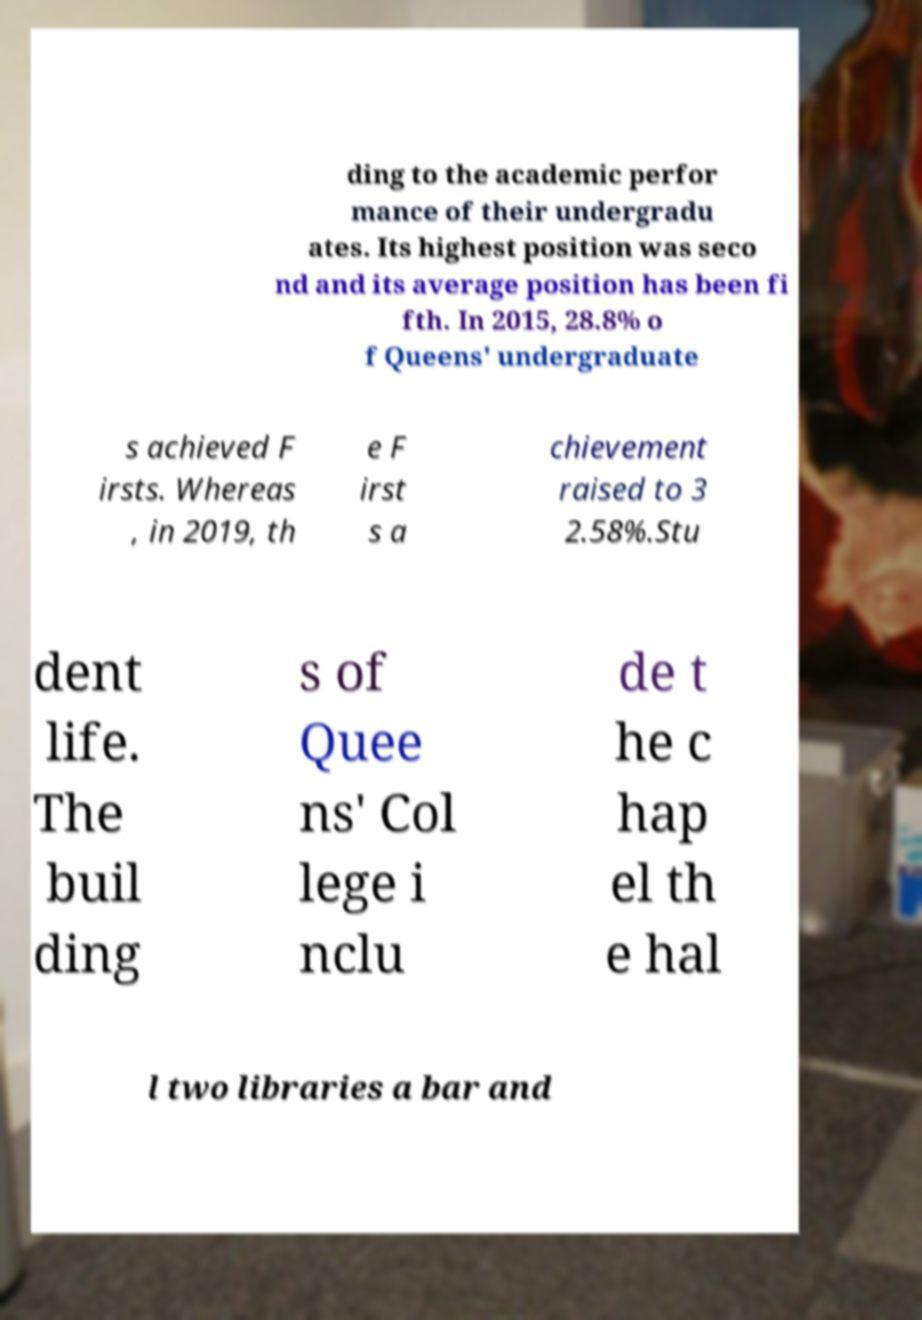There's text embedded in this image that I need extracted. Can you transcribe it verbatim? ding to the academic perfor mance of their undergradu ates. Its highest position was seco nd and its average position has been fi fth. In 2015, 28.8% o f Queens' undergraduate s achieved F irsts. Whereas , in 2019, th e F irst s a chievement raised to 3 2.58%.Stu dent life. The buil ding s of Quee ns' Col lege i nclu de t he c hap el th e hal l two libraries a bar and 